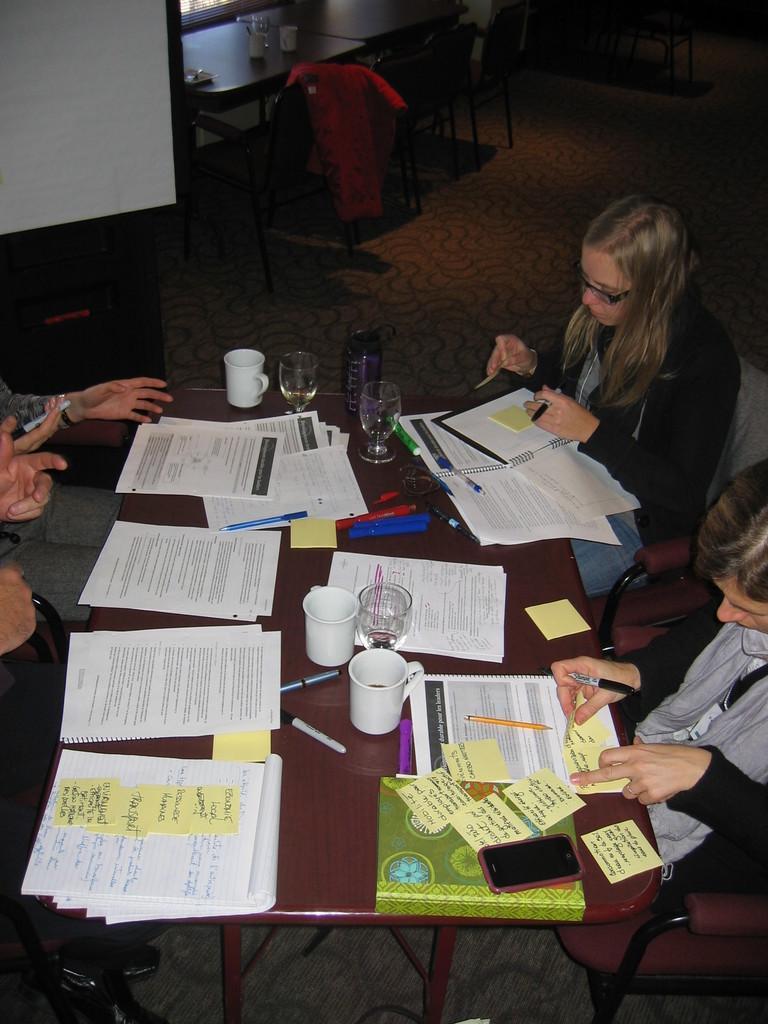Please provide a concise description of this image. In this image there are group of sitting at the table. There are paper, cups, glasses, pens, phone on the table. At the back there is a screen and there is a table and chairs. 